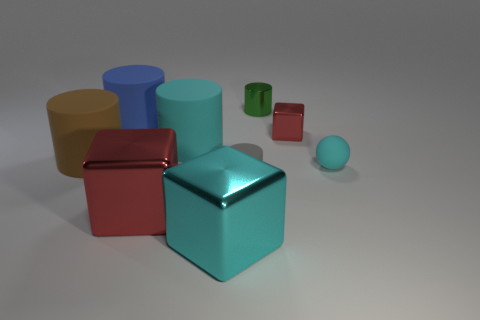Subtract all big cubes. How many cubes are left? 1 Subtract all blue cylinders. How many red blocks are left? 2 Subtract all blue cylinders. How many cylinders are left? 4 Add 1 small spheres. How many objects exist? 10 Subtract all cylinders. How many objects are left? 4 Subtract 0 purple cubes. How many objects are left? 9 Subtract 3 blocks. How many blocks are left? 0 Subtract all red blocks. Subtract all gray spheres. How many blocks are left? 1 Subtract all rubber spheres. Subtract all tiny rubber balls. How many objects are left? 7 Add 5 small green objects. How many small green objects are left? 6 